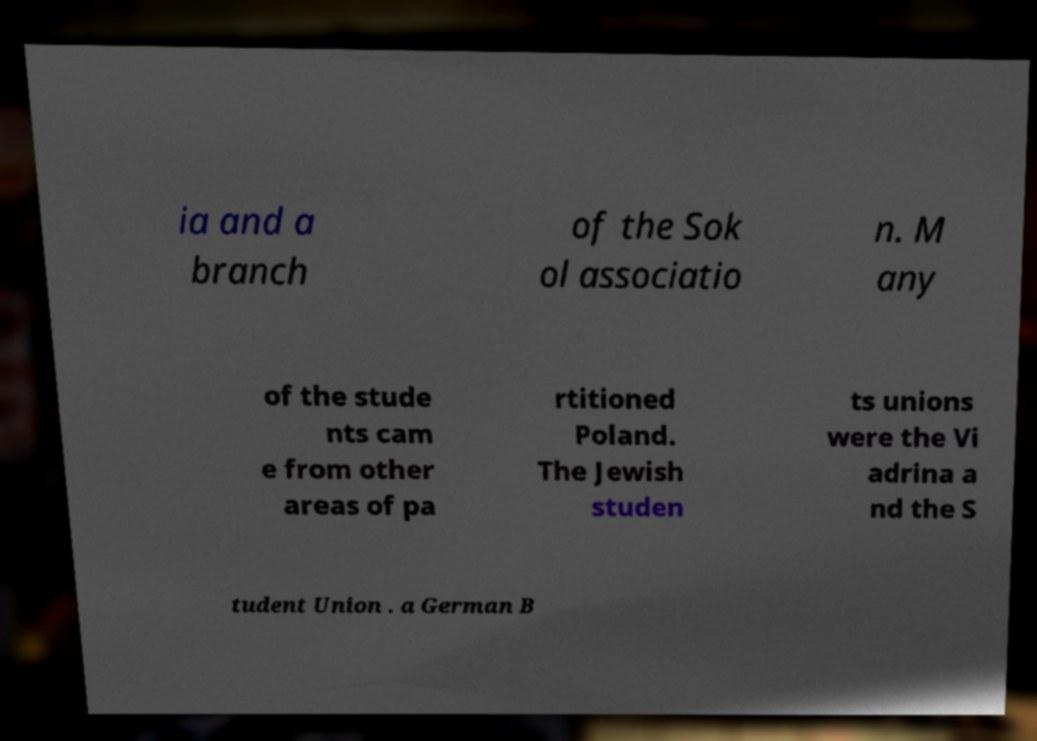Can you read and provide the text displayed in the image?This photo seems to have some interesting text. Can you extract and type it out for me? ia and a branch of the Sok ol associatio n. M any of the stude nts cam e from other areas of pa rtitioned Poland. The Jewish studen ts unions were the Vi adrina a nd the S tudent Union . a German B 